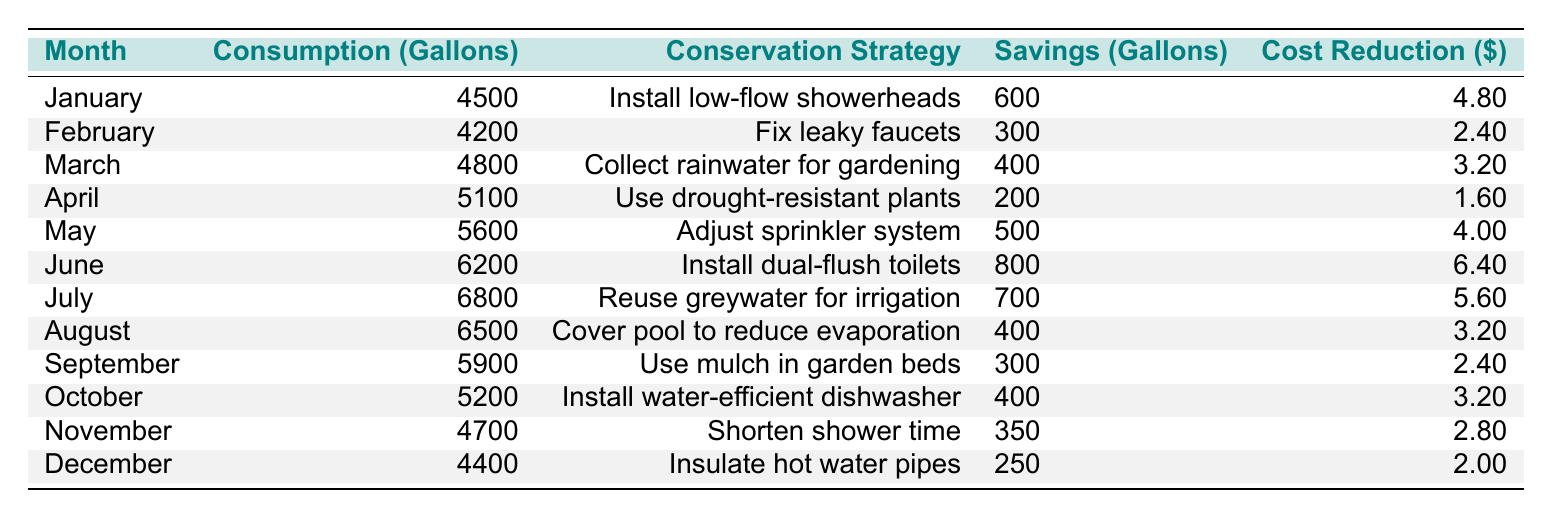What was the total water consumption in July? The table shows the monthly consumption values. For July, it lists 6800 gallons as the consumption.
Answer: 6800 gallons How much water could be saved by installing dual-flush toilets in June? The savings for June when installing dual-flush toilets is noted as 800 gallons in the table.
Answer: 800 gallons Which month had the highest cost reduction and how much was it? By looking at the table, June had the highest cost reduction value of $6.40.
Answer: $6.40 What was the average monthly consumption over the year? To find the average, sum the monthly consumptions: 4500 + 4200 + 4800 + 5100 + 5600 + 6200 + 6800 + 6500 + 5900 + 5200 + 4700 + 4400 = 64600 gallons. Dividing by 12 months gives an average of 64600/12 ≈ 5383.33 gallons.
Answer: Approximately 5383.33 gallons Did fixing leaky faucets in February save more than using mulch in September? The savings from fixing leaky faucets in February is 300 gallons, while using mulch in September also provides 300 gallons in savings. Since both are equal, the answer is no, it did not save more.
Answer: No In which month was the least amount of water saved, and what was the amount? By checking the savings column, April has the lowest savings at 200 gallons for using drought-resistant plants.
Answer: 200 gallons What is the total water savings gained from all conservation strategies in the year? To find the total savings, add all the savings: 600 + 300 + 400 + 200 + 500 + 800 + 700 + 400 + 300 + 400 + 350 + 250 = 4850 gallons.
Answer: 4850 gallons Is using a water-efficient dishwasher in October more effective in saving water than using drought-resistant plants in April? The savings from the dishwasher in October is 400 gallons, while using drought-resistant plants in April yields only 200 gallons in savings. Therefore, installing a water-efficient dishwasher is more effective.
Answer: Yes What was the total cost reduction for the entire year? Summing the cost reductions: 4.80 + 2.40 + 3.20 + 1.60 + 4.00 + 6.40 + 5.60 + 3.20 + 2.40 + 3.20 + 2.80 + 2.00 = 38.40 dollars for the year.
Answer: $38.40 Which month reported the highest water consumption and what was the amount? In the table, July shows the highest reported water consumption at 6800 gallons.
Answer: 6800 gallons 